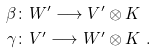Convert formula to latex. <formula><loc_0><loc_0><loc_500><loc_500>\beta & \colon W ^ { \prime } \longrightarrow V ^ { \prime } \otimes K \\ \gamma & \colon V ^ { \prime } \longrightarrow W ^ { \prime } \otimes K \ .</formula> 